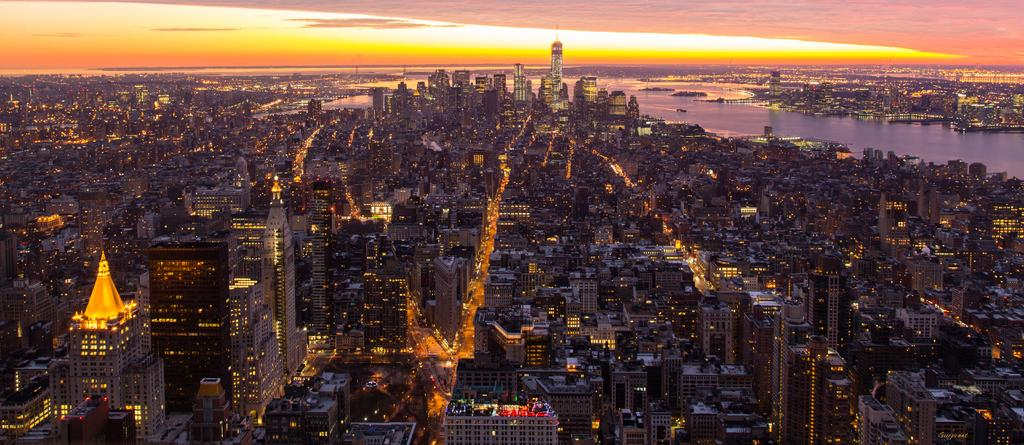What type of view is shown in the image? The image is an aerial view. What can be seen from this perspective? There are many buildings visible in the image. Are there any other elements visible besides the buildings? Yes, there are lights and water visible in the image. What is visible at the top of the image? The sky is visible at the top of the image. How does the veil blow in the wind in the image? There is no veil present in the image; it is an aerial view of buildings, lights, water, and the sky. 